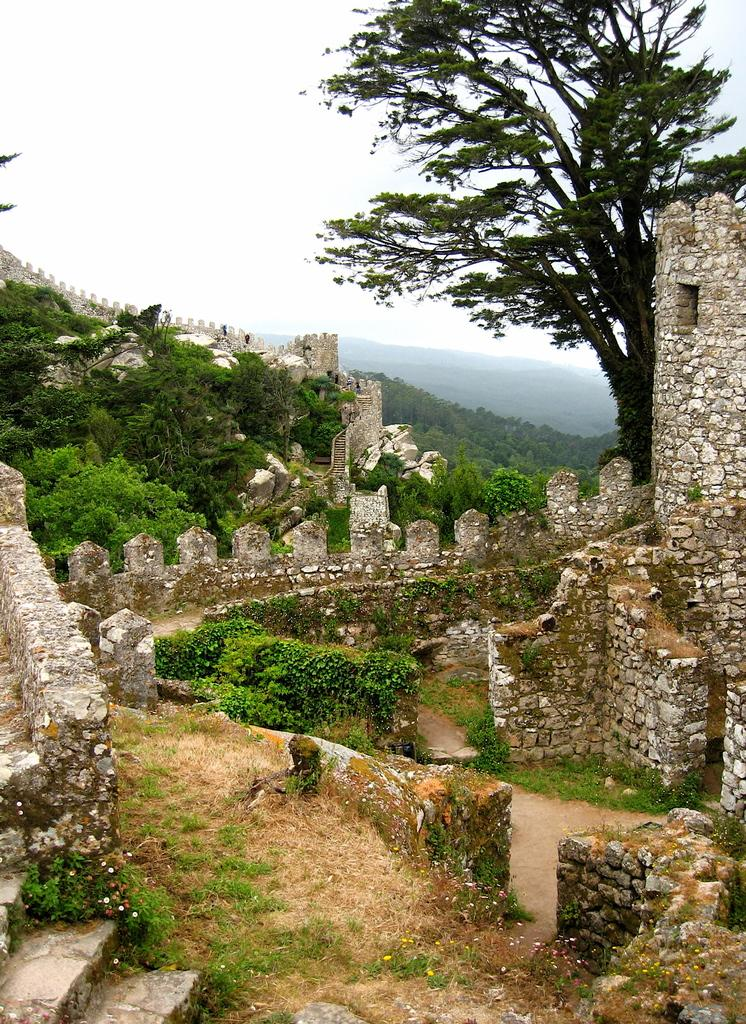What is the main subject in the middle of the image? There is a wall on a mountain in the middle of the image. What can be seen in the background of the image? There are trees in the background of the image. What is visible at the top of the image? The sky is visible at the top of the image. What type of plants can be seen growing on the prison wall in the image? There is no prison or plants growing on a wall in the image; it features a wall on a mountain with trees in the background and the sky visible at the top. 